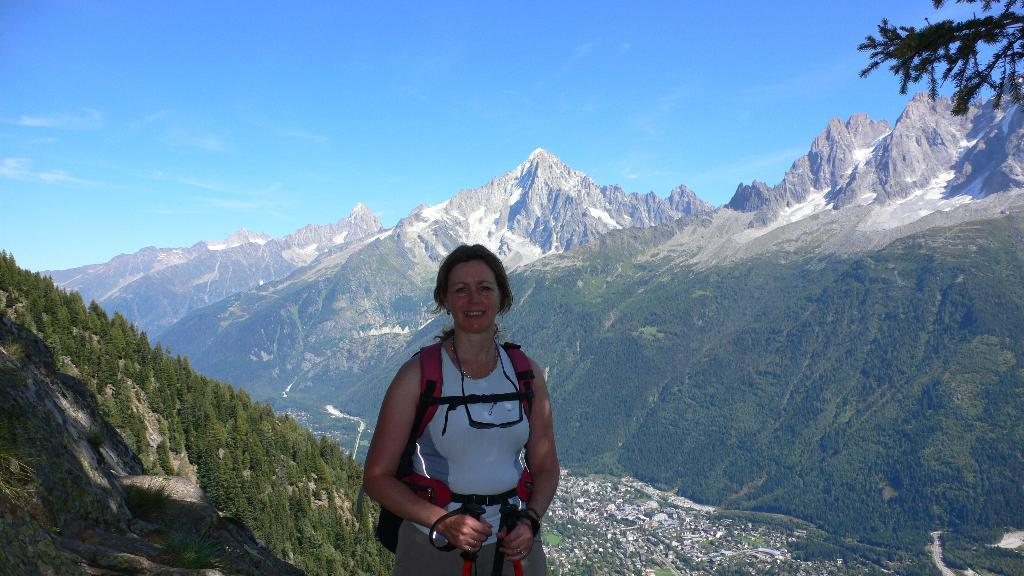What is the main subject of the image? There is a woman in the image. What is the woman doing in the image? The woman is standing. What is the woman wearing in the image? The woman is wearing a bag. What is the woman holding in her hand in the image? The woman is holding sticks in her hand. What can be seen in the background of the image? There are mountains and the sky visible in the background of the image. What type of skin can be seen on the woman's face in the image? There is no information provided about the woman's skin in the image. What type of straw is the woman using to drink in the image? There is no straw present in the image; the woman is holding sticks in her hand. 